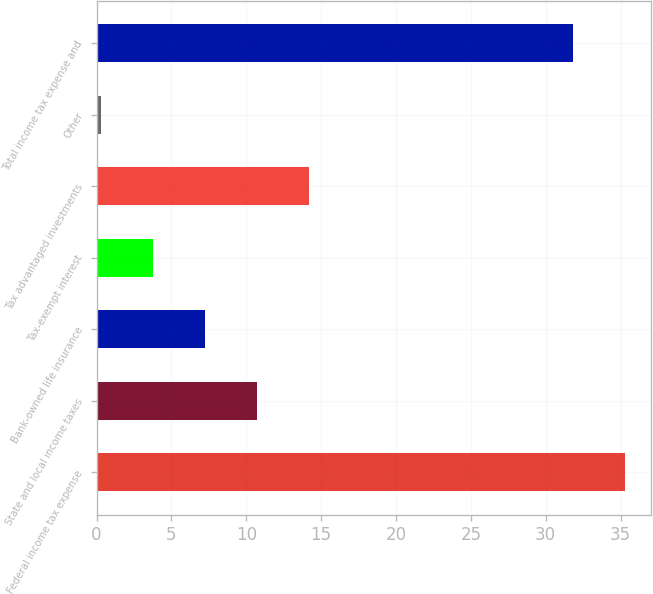Convert chart to OTSL. <chart><loc_0><loc_0><loc_500><loc_500><bar_chart><fcel>US Federal income tax expense<fcel>State and local income taxes<fcel>Bank-owned life insurance<fcel>Tax-exempt interest<fcel>Tax advantaged investments<fcel>Other<fcel>Total income tax expense and<nl><fcel>35.27<fcel>10.71<fcel>7.24<fcel>3.77<fcel>14.18<fcel>0.3<fcel>31.8<nl></chart> 